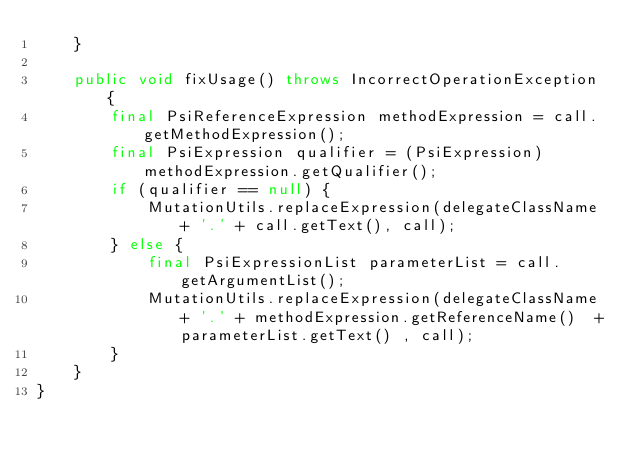<code> <loc_0><loc_0><loc_500><loc_500><_Java_>    }

    public void fixUsage() throws IncorrectOperationException {
        final PsiReferenceExpression methodExpression = call.getMethodExpression();
        final PsiExpression qualifier = (PsiExpression) methodExpression.getQualifier();
        if (qualifier == null) {
            MutationUtils.replaceExpression(delegateClassName + '.' + call.getText(), call);
        } else {
            final PsiExpressionList parameterList = call.getArgumentList();
            MutationUtils.replaceExpression(delegateClassName + '.' + methodExpression.getReferenceName()  +parameterList.getText() , call);
        }
    }
}
</code> 